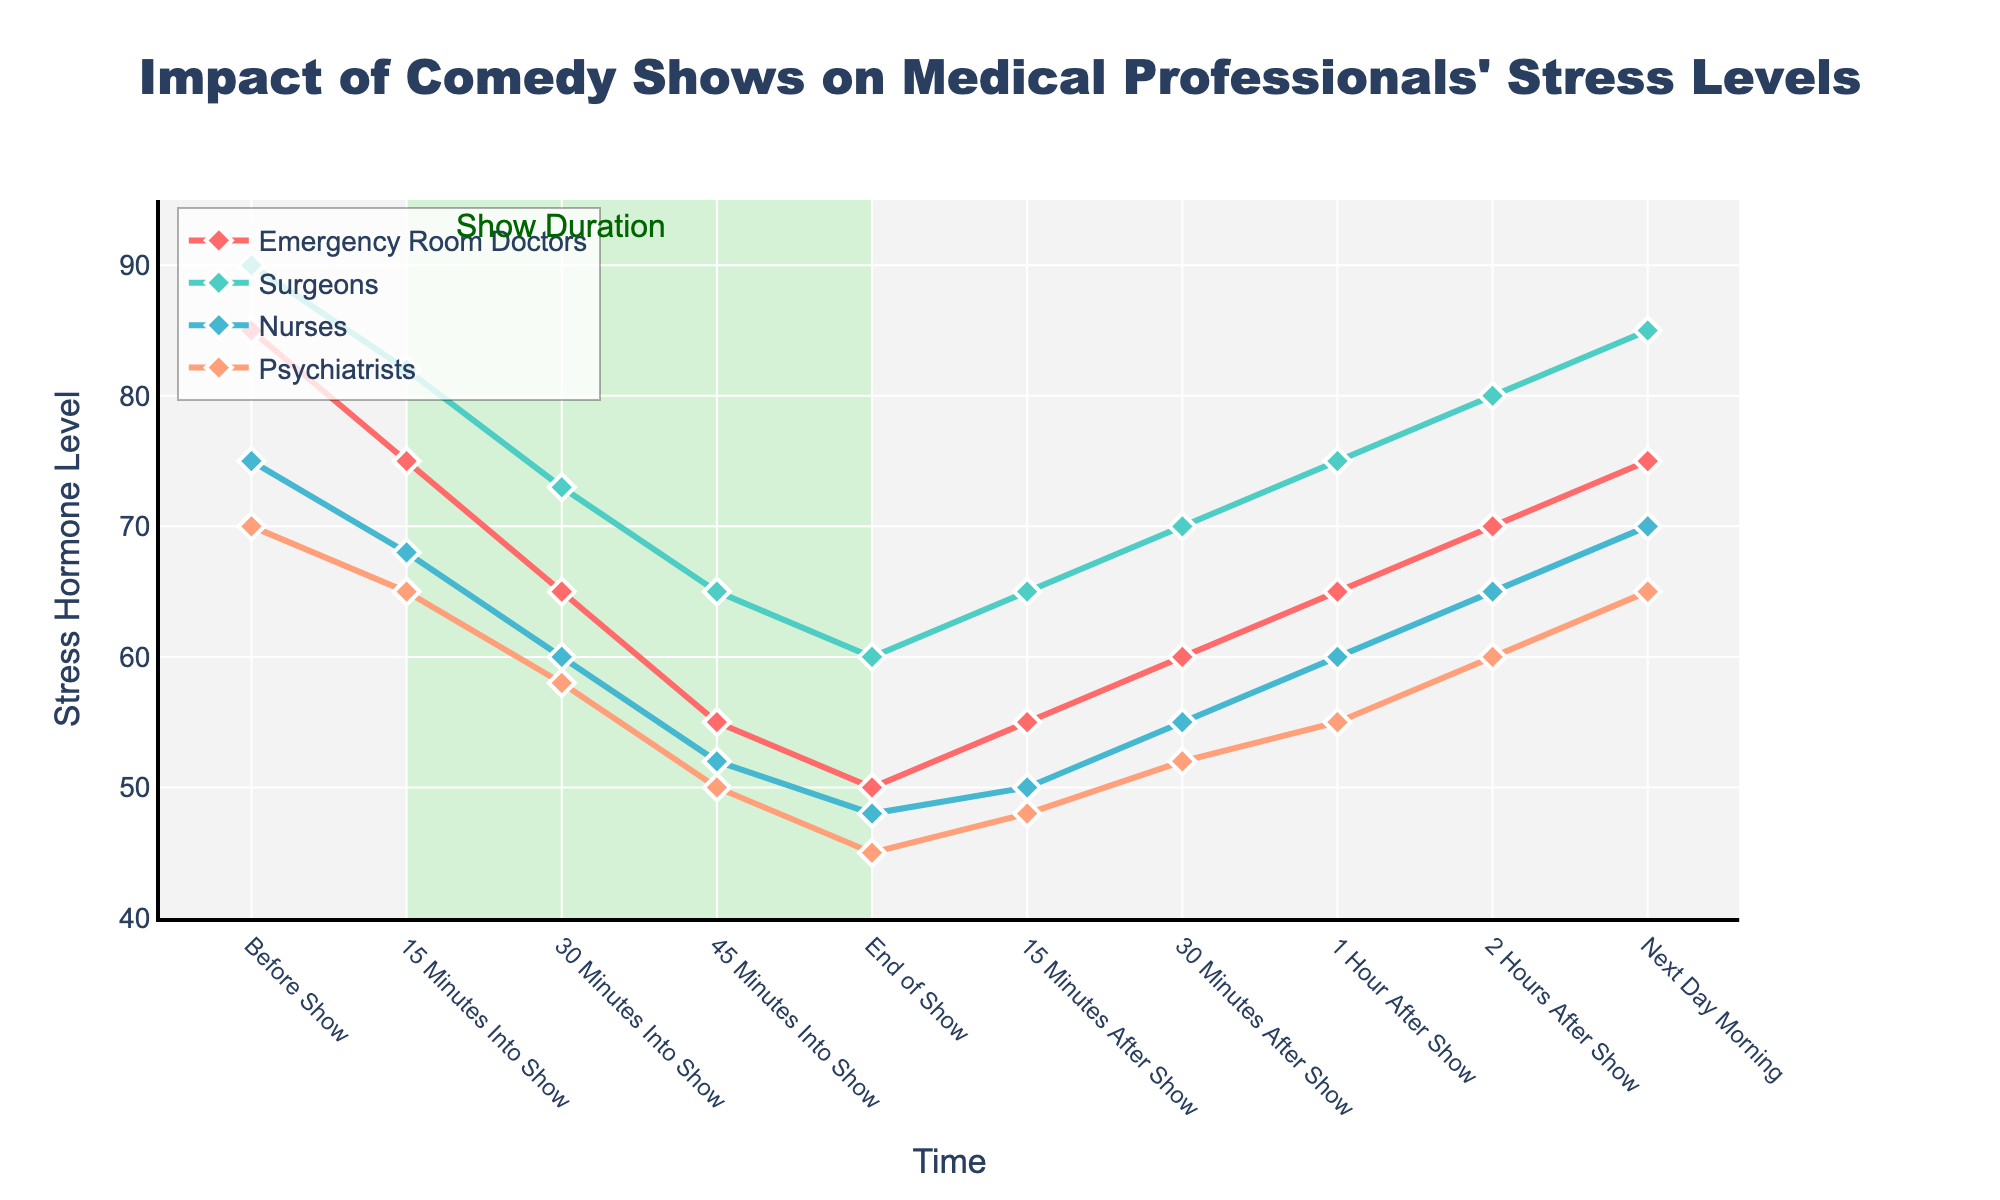What is the trend of stress hormone levels for Nurses from the start to the end of the comedy show? The stress hormone levels for Nurses decrease steadily from 75 before the show to 48 at the end of the show.
Answer: Decreasing Which profession shows the largest decrease in stress hormone levels from "Before Show" to "End of Show"? Emergency Room Doctors decrease from 85 to 50, so the decrease is 85 - 50 = 35 units. Surgeons decrease from 90 to 60, giving a decrease of 30 units. Nurses decrease from 75 to 48, which is 27 units, and Psychiatrists decrease from 70 to 45, a decrease of 25 units. Therefore, Emergency Room Doctors show the largest decrease.
Answer: Emergency Room Doctors Compare the stress levels of Surgeons and Psychiatrists 45 minutes into the show. Which one is lower? At 45 minutes into the show, Surgeons have a stress hormone level of 65, while Psychiatrists have a level of 50. Since 50 is less than 65, Psychiatrists have a lower stress hormone level.
Answer: Psychiatrists How does the stress level of Psychiatrists change from "End of Show" to "2 Hours After Show"? The stress level increases from 45 at the "End of Show" to 60 "2 Hours After Show," an increase of 60 - 45 = 15 units.
Answer: Increases What color line represents the Surgeons in the plot? The Surgeons are represented by a line that is turquoise in color.
Answer: Turquoise What is the difference in stress hormone levels between "1 Hour After Show" and "Next Day Morning" for Nurses? The stress hormone level for Nurses is 60 "1 Hour After Show" and 70 "Next Day Morning." The difference is 70 - 60 = 10 units.
Answer: 10 units Does any profession's stress hormone level return to its initial value by the "Next Day Morning"? By the "Next Day Morning," Emergency Room Doctors' stress level is 75, which is less than their initial 85. Surgeons' level is 85, which is less than their initial 90. Nurses' level is 70, which matches their initial. Psychiatrists' level is 65, less than their initial 70. Only Nurses' stress hormone level returns to its initial value.
Answer: Nurses Which time point shows Psychiatrists' lowest stress hormone level during the entire observed period? The lowest stress hormone level for Psychiatrists is 45, which occurs at the "End of Show."
Answer: End of Show 